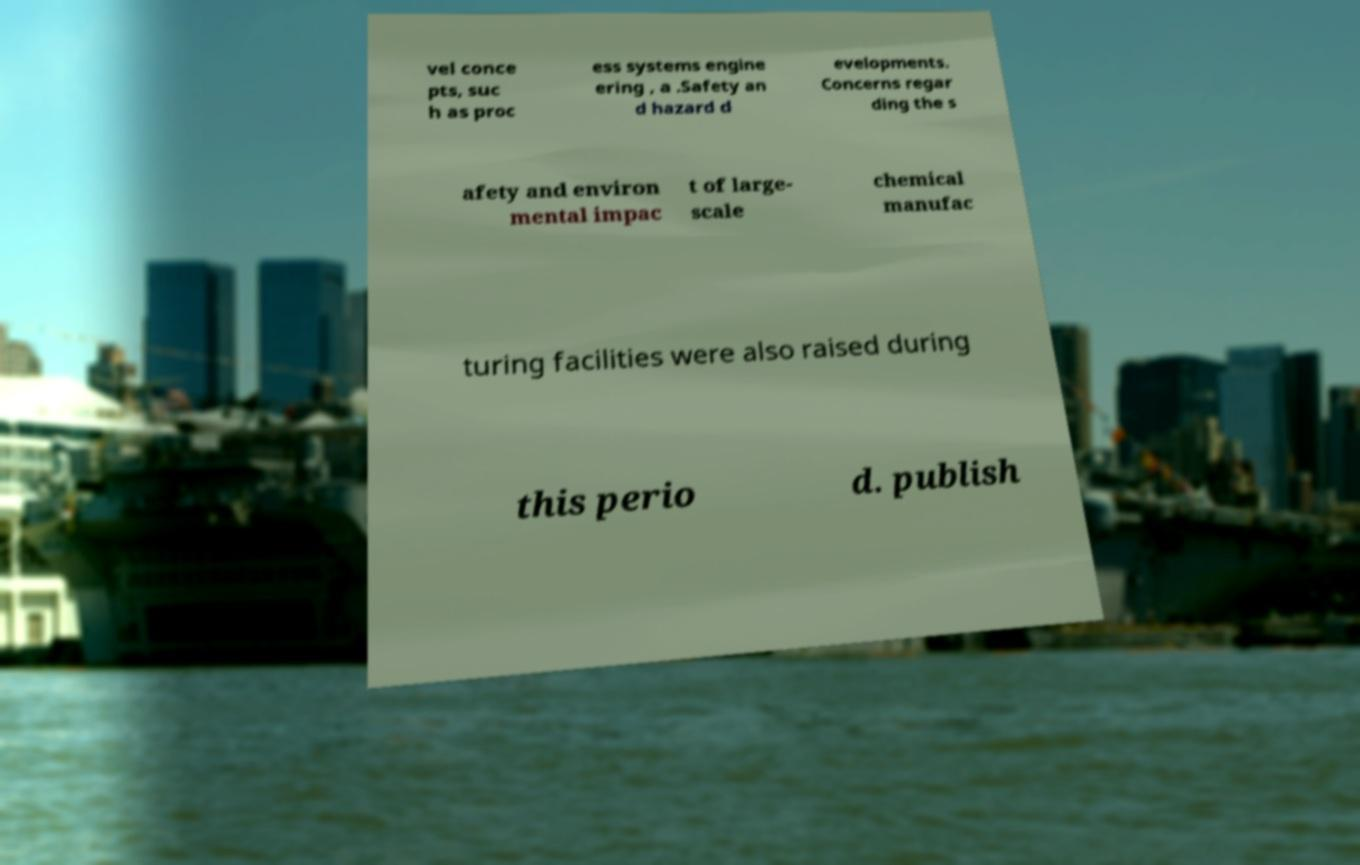There's text embedded in this image that I need extracted. Can you transcribe it verbatim? vel conce pts, suc h as proc ess systems engine ering , a .Safety an d hazard d evelopments. Concerns regar ding the s afety and environ mental impac t of large- scale chemical manufac turing facilities were also raised during this perio d. publish 